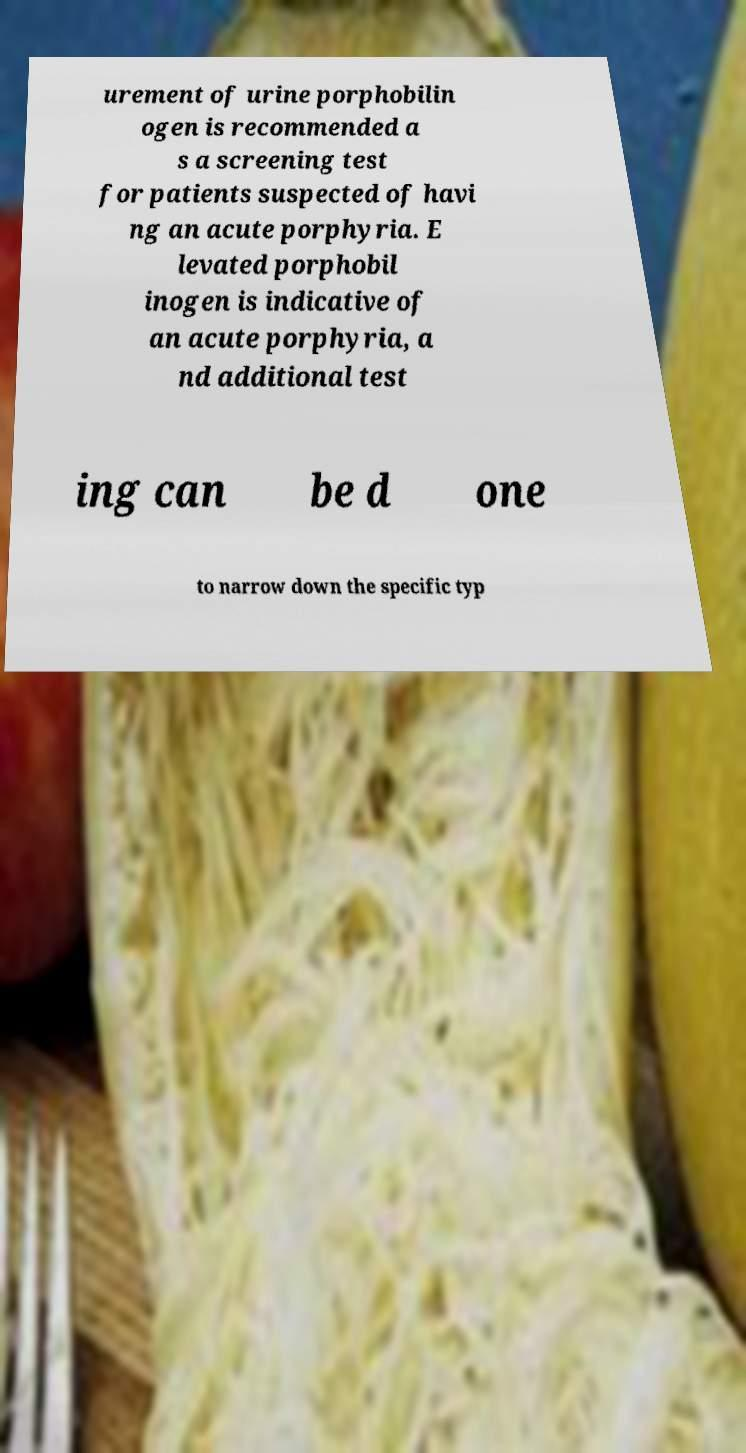What messages or text are displayed in this image? I need them in a readable, typed format. urement of urine porphobilin ogen is recommended a s a screening test for patients suspected of havi ng an acute porphyria. E levated porphobil inogen is indicative of an acute porphyria, a nd additional test ing can be d one to narrow down the specific typ 